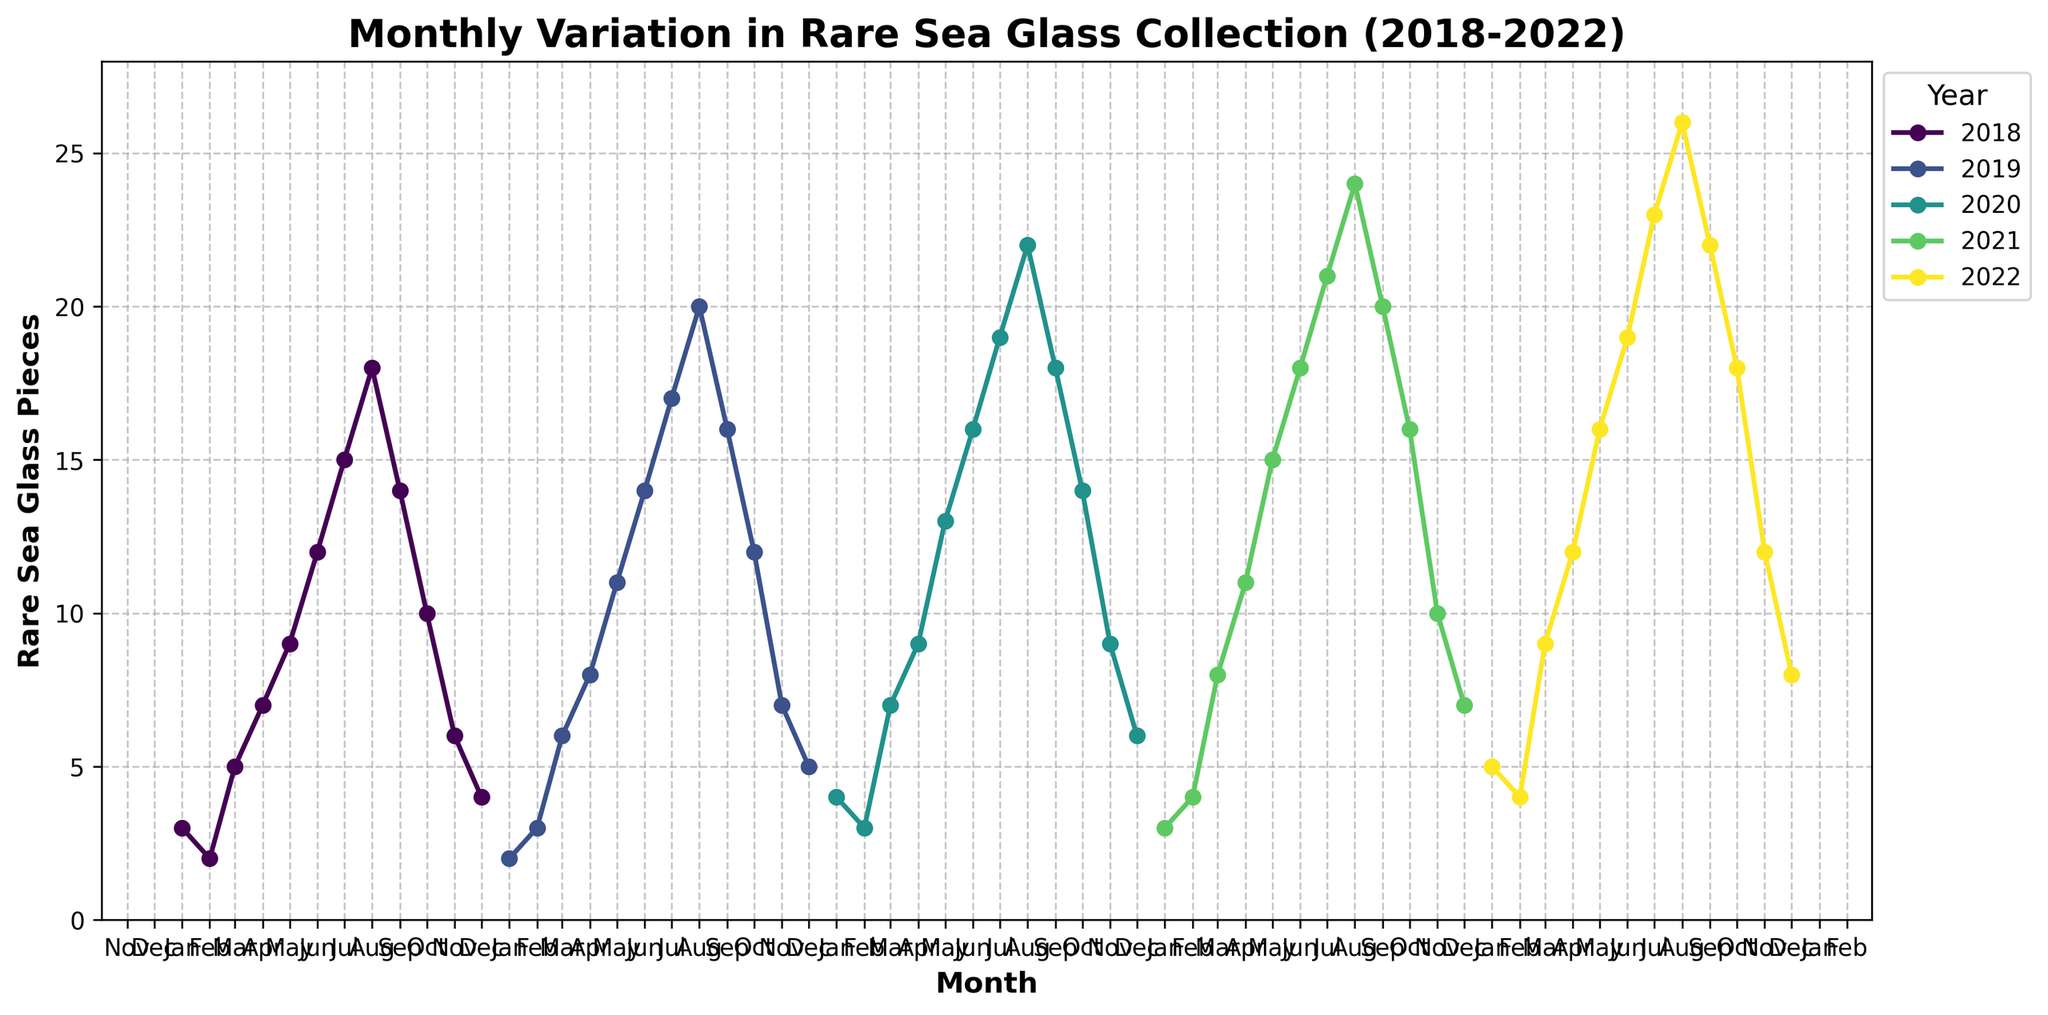What month had the highest number of rare sea glass pieces collected in 2020? In the year 2020, the peak is at the month of August with 22 rare sea glass pieces collected.
Answer: August Between which two consecutive months in 2019 did the number of rare sea glass pieces collected increase the most? Analyze each month's difference in 2019: 
- February to March: 3
- March to April: 2
- April to May: 3
- May to June: 3
- June to July: 3
- July to August: 3
- August to September: -4
- September to October: -4
- October to November: -5
- November to December: -2
The maximum increase is from June to July by 3 pieces.
Answer: June to July Which year saw the highest overall increase in rare sea glass pieces from January to December? Calculate the difference for each year: 
- 2018: 4 - 3 = 1
- 2019: 5 - 2 = 3
- 2020: 6 - 4 = 2
- 2021: 7 - 3 = 4
- 2022: 8 - 5 = 3
The highest increase is in 2021 with a 4-piece gain from January to December.
Answer: 2021 By how many pieces did the rare sea glass collection increase from March to August in 2022? In March 2022, 9 pieces were collected. In August 2022, 26 pieces were collected. The difference is 26 - 9 = 17 pieces.
Answer: 17 pieces In which month does the collection consistently decrease after August each year? Observe the pattern of data points post-August for each year: the number of rare sea glass pieces consistently decreases every year after August, starting in September.
Answer: September Compare the number of rare sea glass pieces collected in July of each year. Which year had the most pieces? For each July from 2018 to 2022:
- 2018: 15
- 2019: 17
- 2020: 19
- 2021: 21
- 2022: 23
The year with the most pieces collected in July is 2022 with 23 pieces.
Answer: 2022 What is the average number of rare sea glass pieces collected in May over the five-year period? Summing up May's data for all years: 9 (2018) + 11 (2019) + 13 (2020) + 15 (2021) + 16 (2022) = 64. Divide by 5 gives an average: 64 / 5 = 12.8 pieces.
Answer: 12.8 pieces 